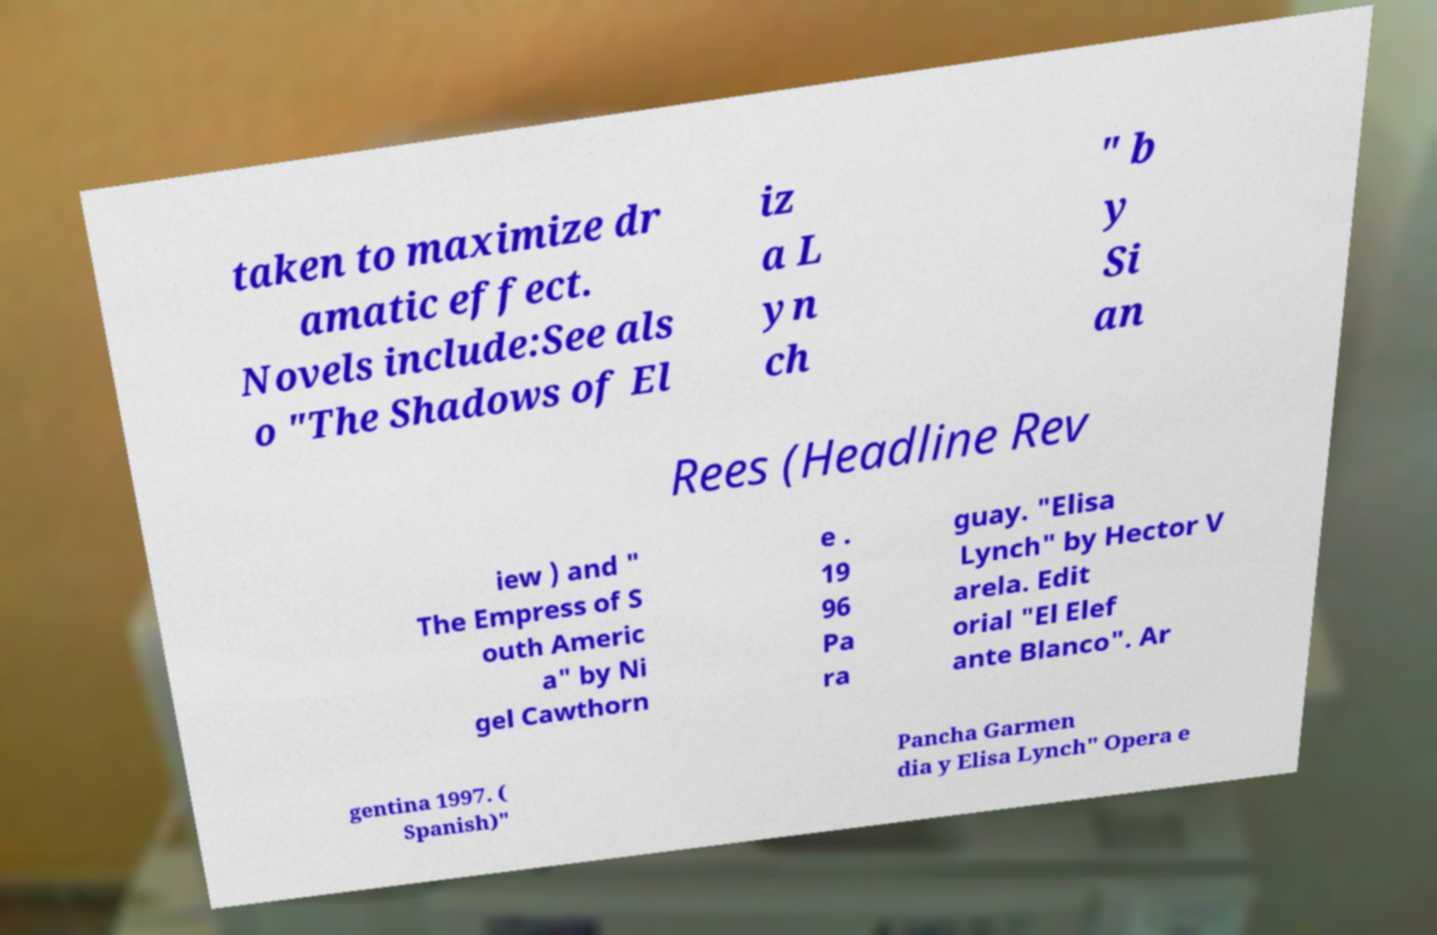Could you extract and type out the text from this image? taken to maximize dr amatic effect. Novels include:See als o "The Shadows of El iz a L yn ch " b y Si an Rees (Headline Rev iew ) and " The Empress of S outh Americ a" by Ni gel Cawthorn e . 19 96 Pa ra guay. "Elisa Lynch" by Hector V arela. Edit orial "El Elef ante Blanco". Ar gentina 1997. ( Spanish)" Pancha Garmen dia y Elisa Lynch" Opera e 